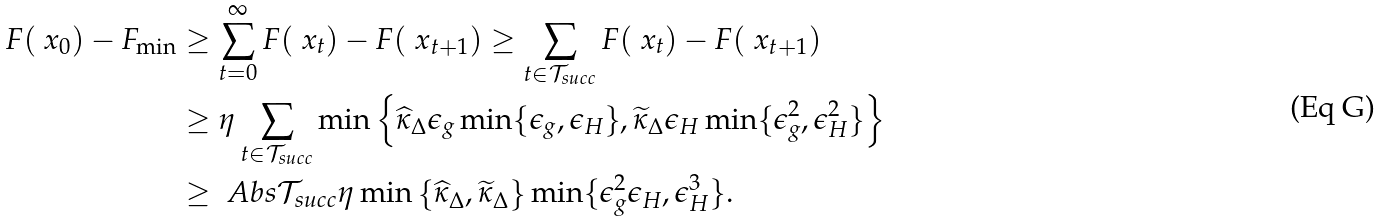<formula> <loc_0><loc_0><loc_500><loc_500>F ( \ x _ { 0 } ) - F _ { \min } & \geq \sum _ { t = 0 } ^ { \infty } F ( \ x _ { t } ) - F ( \ x _ { t + 1 } ) \geq \sum _ { t \in \mathcal { T } _ { s u c c } } F ( \ x _ { t } ) - F ( \ x _ { t + 1 } ) \\ & \geq \eta \sum _ { t \in \mathcal { T } _ { s u c c } } \min \left \{ \widehat { \kappa } _ { \Delta } \epsilon _ { g } \min \{ \epsilon _ { g } , \epsilon _ { H } \} , \widetilde { \kappa } _ { \Delta } \epsilon _ { H } \min \{ \epsilon _ { g } ^ { 2 } , \epsilon _ { H } ^ { 2 } \} \right \} \\ & \geq \ A b s { \mathcal { T } _ { s u c c } } \eta \min \left \{ \widehat { \kappa } _ { \Delta } , \widetilde { \kappa } _ { \Delta } \right \} \min \{ \epsilon _ { g } ^ { 2 } \epsilon _ { H } , \epsilon _ { H } ^ { 3 } \} .</formula> 